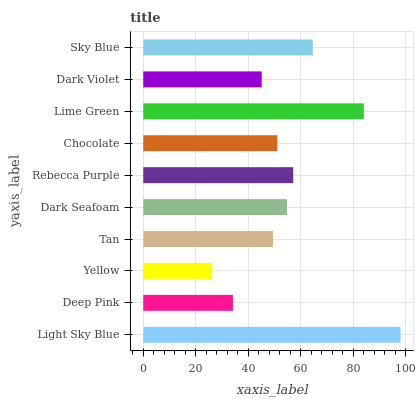Is Yellow the minimum?
Answer yes or no. Yes. Is Light Sky Blue the maximum?
Answer yes or no. Yes. Is Deep Pink the minimum?
Answer yes or no. No. Is Deep Pink the maximum?
Answer yes or no. No. Is Light Sky Blue greater than Deep Pink?
Answer yes or no. Yes. Is Deep Pink less than Light Sky Blue?
Answer yes or no. Yes. Is Deep Pink greater than Light Sky Blue?
Answer yes or no. No. Is Light Sky Blue less than Deep Pink?
Answer yes or no. No. Is Dark Seafoam the high median?
Answer yes or no. Yes. Is Chocolate the low median?
Answer yes or no. Yes. Is Lime Green the high median?
Answer yes or no. No. Is Deep Pink the low median?
Answer yes or no. No. 